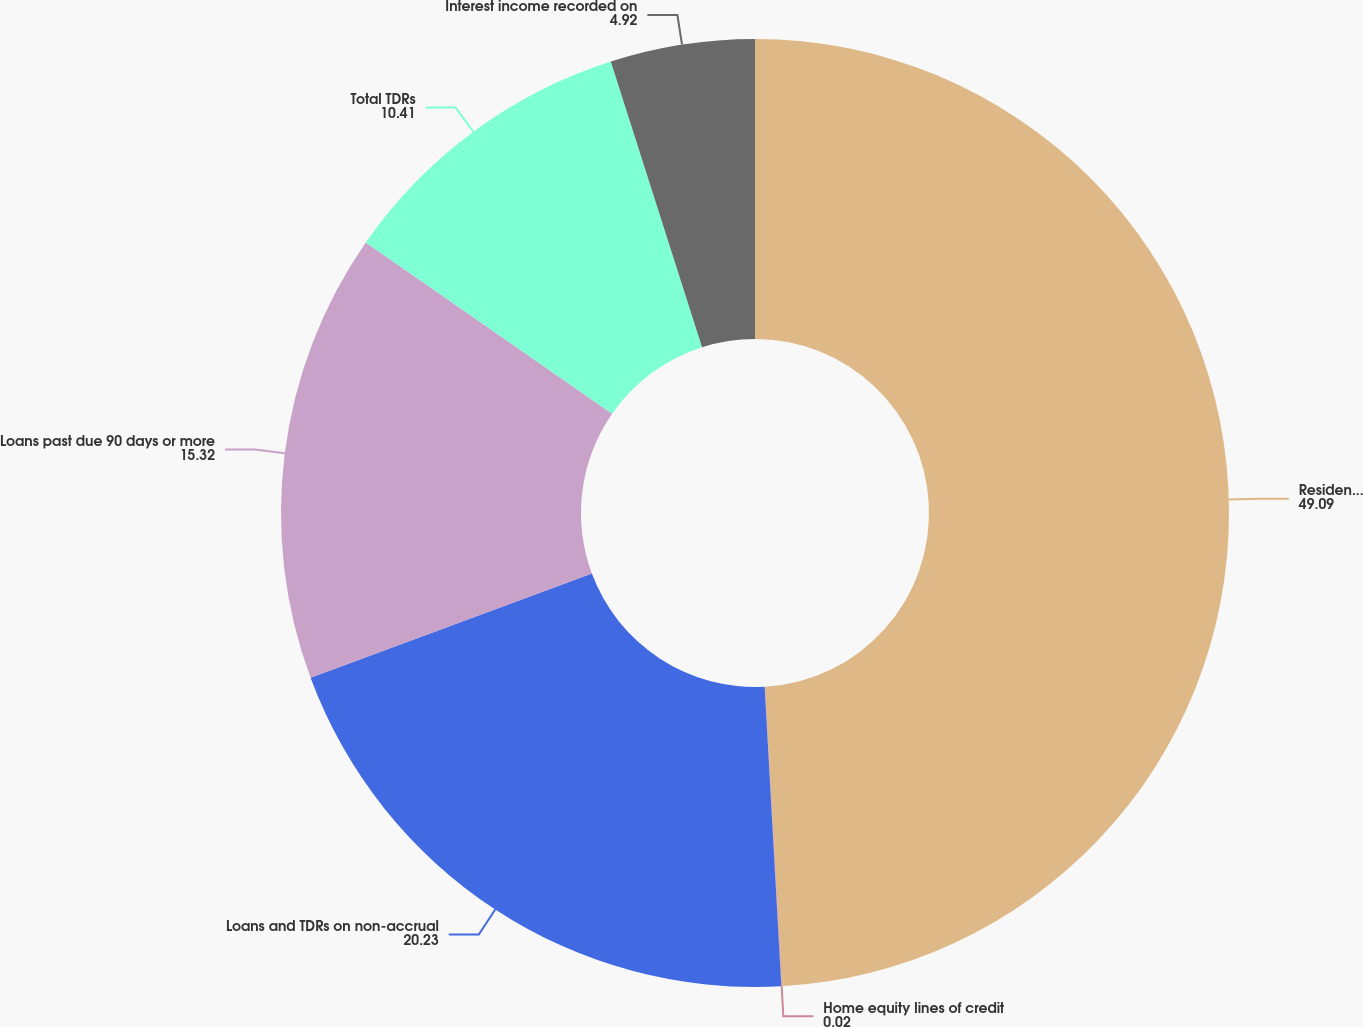Convert chart to OTSL. <chart><loc_0><loc_0><loc_500><loc_500><pie_chart><fcel>Residential real estate<fcel>Home equity lines of credit<fcel>Loans and TDRs on non-accrual<fcel>Loans past due 90 days or more<fcel>Total TDRs<fcel>Interest income recorded on<nl><fcel>49.09%<fcel>0.02%<fcel>20.23%<fcel>15.32%<fcel>10.41%<fcel>4.92%<nl></chart> 